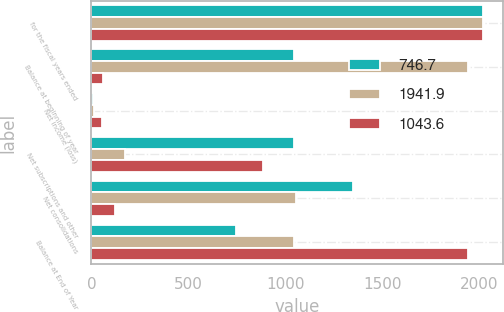Convert chart. <chart><loc_0><loc_0><loc_500><loc_500><stacked_bar_chart><ecel><fcel>for the fiscal years ended<fcel>Balance at beginning of year<fcel>Net income (loss)<fcel>Net subscriptions and other<fcel>Net consolidations<fcel>Balance at End of Year<nl><fcel>746.7<fcel>2019<fcel>1043.6<fcel>6.2<fcel>1046.6<fcel>1349.7<fcel>746.7<nl><fcel>1941.9<fcel>2018<fcel>1941.9<fcel>12.8<fcel>170.9<fcel>1056.4<fcel>1043.6<nl><fcel>1043.6<fcel>2017<fcel>61.1<fcel>53<fcel>884.3<fcel>118.8<fcel>1941.9<nl></chart> 